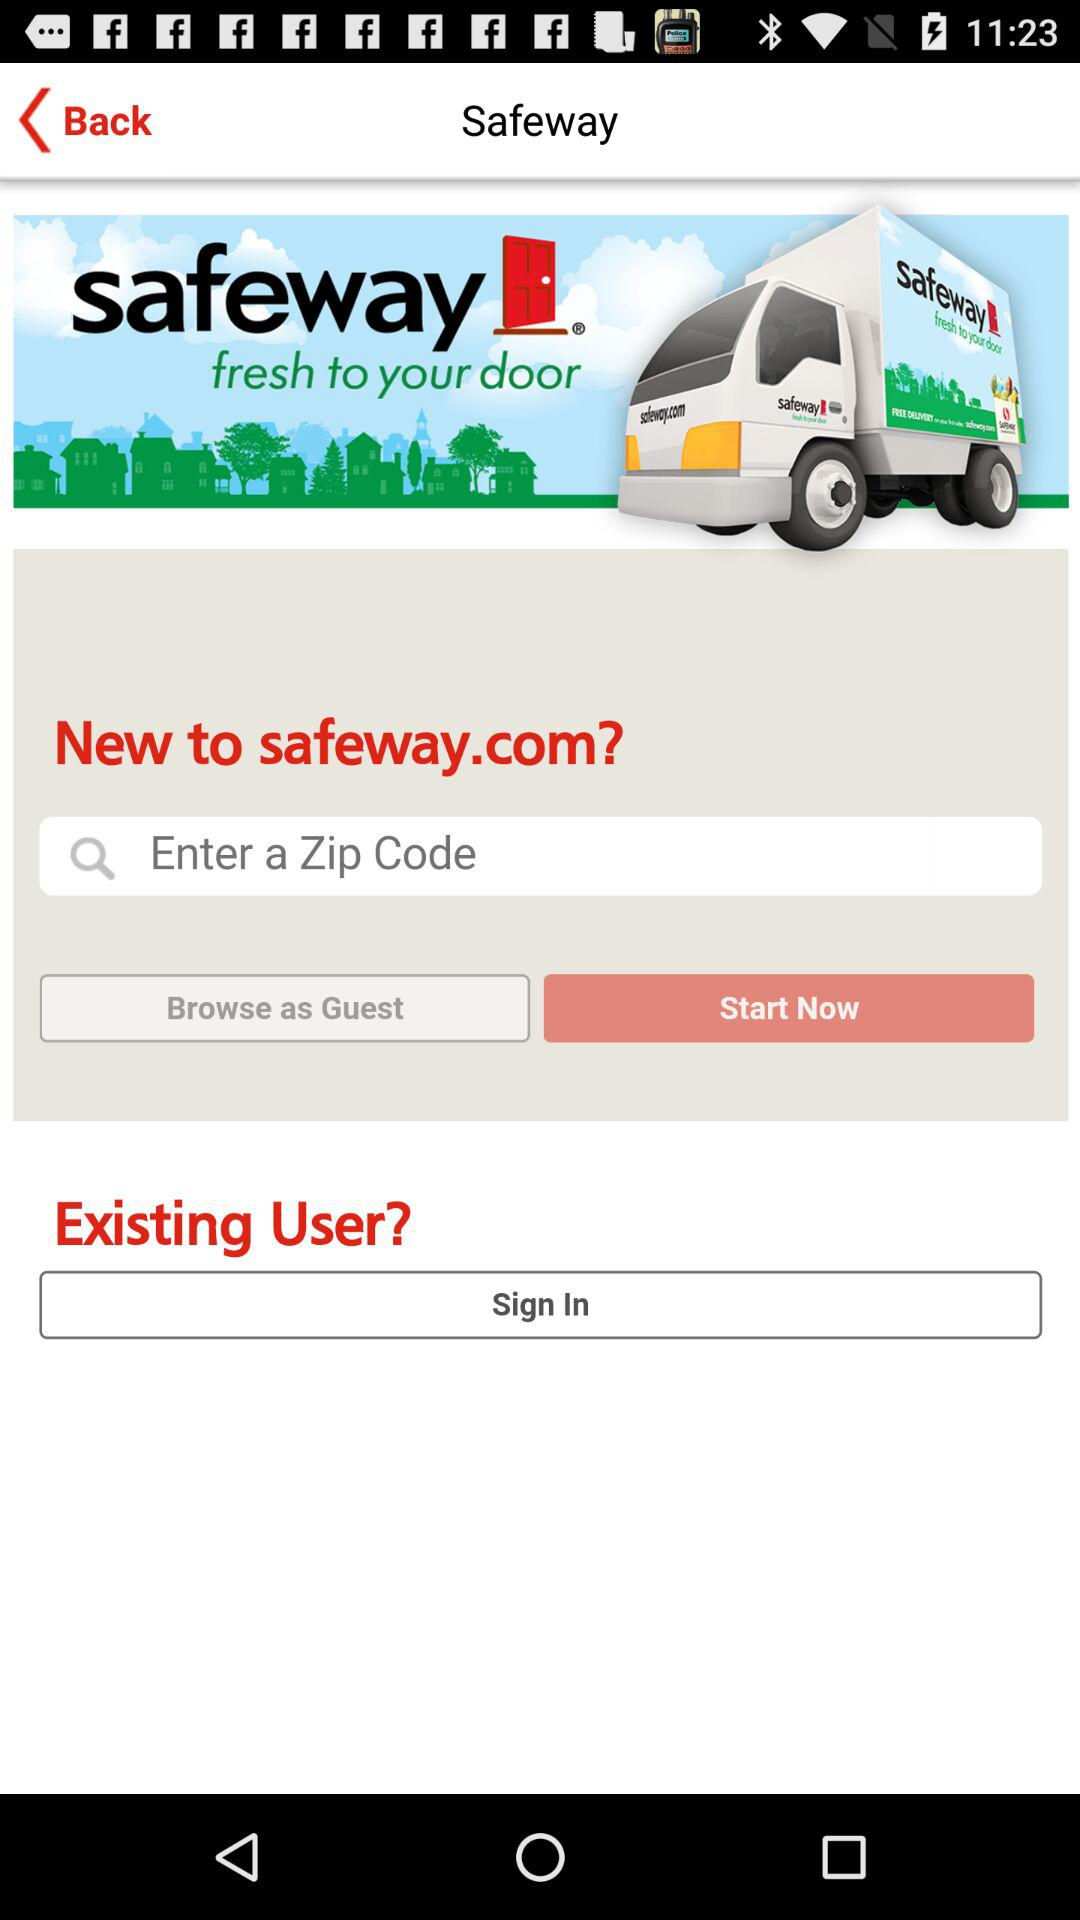How can we browse? You can browse either as a guest or by signing in. 